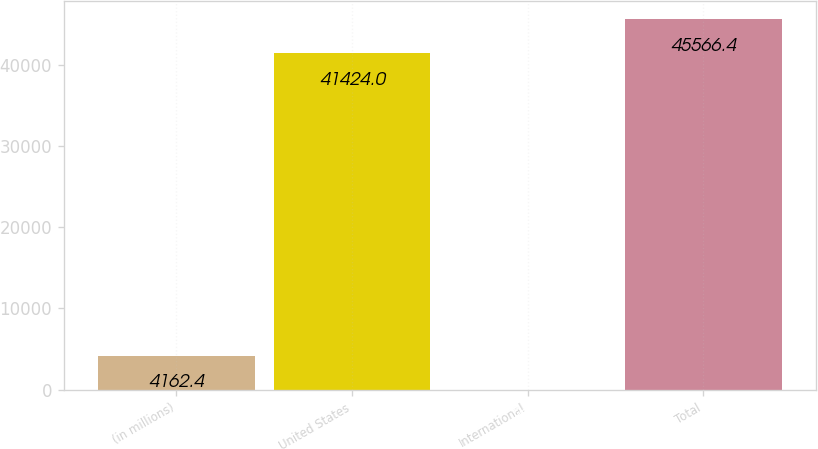Convert chart. <chart><loc_0><loc_0><loc_500><loc_500><bar_chart><fcel>(in millions)<fcel>United States<fcel>International<fcel>Total<nl><fcel>4162.4<fcel>41424<fcel>20<fcel>45566.4<nl></chart> 